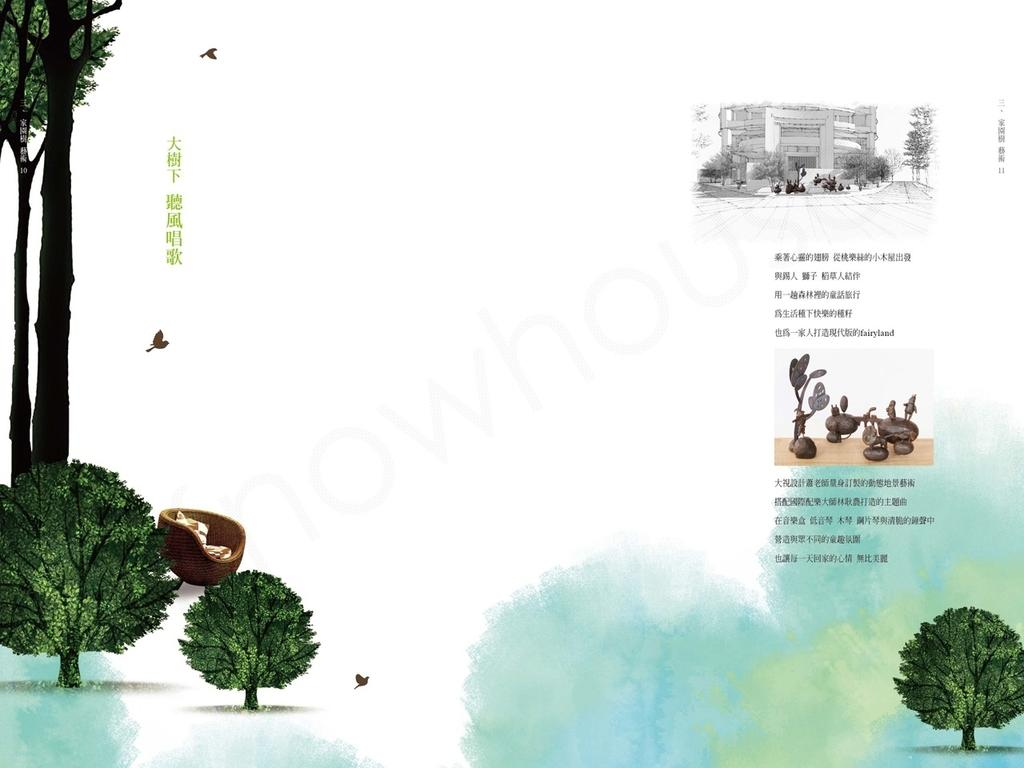What type of object is in the center of the image? There is a paper poster in the image. What can be seen on the left side of the image? There are trees on the left side of the image. What is on the right side of the image? There is a small photography on the right side of the image. What type of text is present in the image? Quotes are present in the image. How many cats can be seen walking through the fog in the image? There are no cats or fog present in the image. Is there a door visible in the image? There is no door visible in the image. 